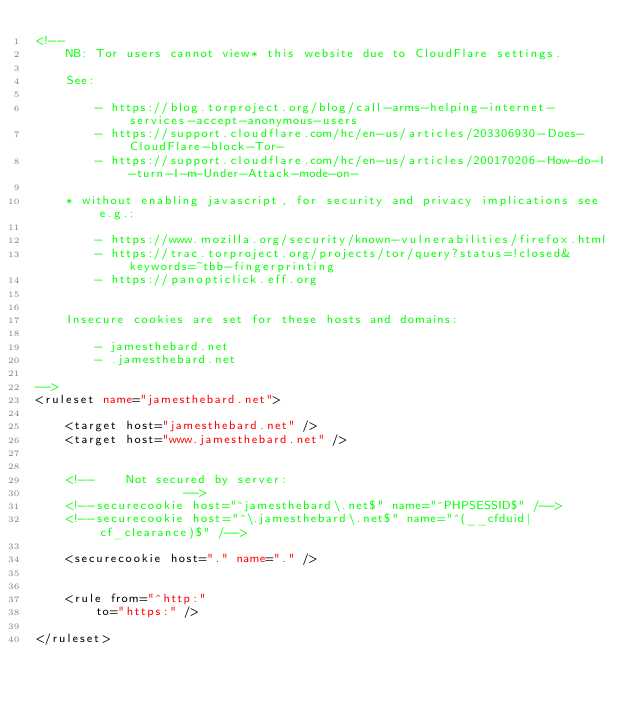<code> <loc_0><loc_0><loc_500><loc_500><_XML_><!--
	NB: Tor users cannot view* this website due to CloudFlare settings.

	See:

		- https://blog.torproject.org/blog/call-arms-helping-internet-services-accept-anonymous-users
		- https://support.cloudflare.com/hc/en-us/articles/203306930-Does-CloudFlare-block-Tor-
		- https://support.cloudflare.com/hc/en-us/articles/200170206-How-do-I-turn-I-m-Under-Attack-mode-on-

	* without enabling javascript, for security and privacy implications see e.g.:

		- https://www.mozilla.org/security/known-vulnerabilities/firefox.html
		- https://trac.torproject.org/projects/tor/query?status=!closed&keywords=~tbb-fingerprinting
		- https://panopticlick.eff.org


	Insecure cookies are set for these hosts and domains:

		- jamesthebard.net
		- .jamesthebard.net

-->
<ruleset name="jamesthebard.net">

	<target host="jamesthebard.net" />
	<target host="www.jamesthebard.net" />


	<!--	Not secured by server:
					-->
	<!--securecookie host="^jamesthebard\.net$" name="^PHPSESSID$" /-->
	<!--securecookie host="^\.jamesthebard\.net$" name="^(__cfduid|cf_clearance)$" /-->

	<securecookie host="." name="." />


	<rule from="^http:"
		to="https:" />

</ruleset>
</code> 